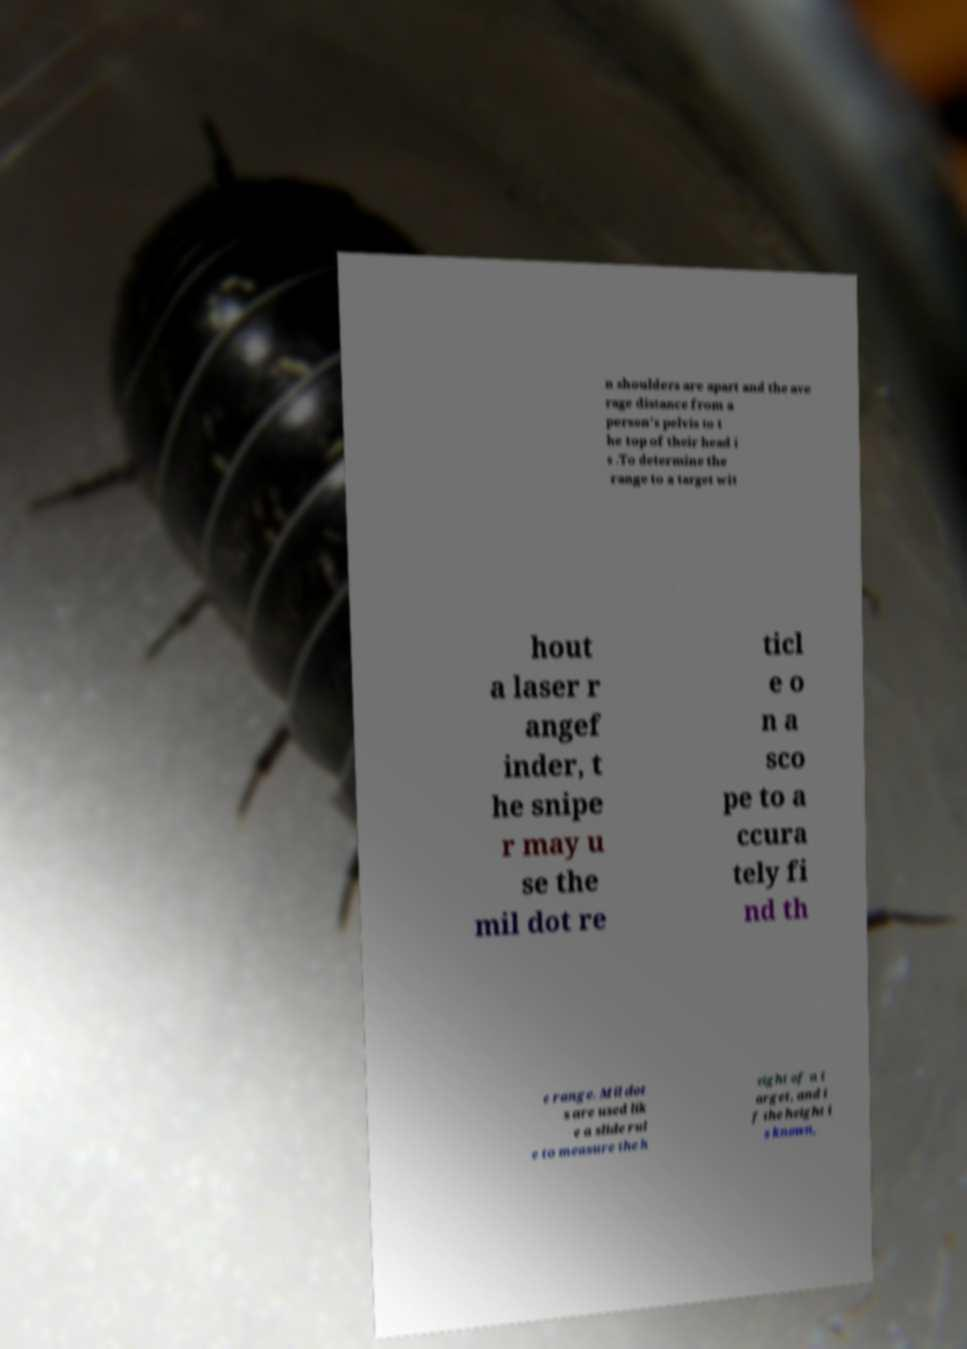Could you assist in decoding the text presented in this image and type it out clearly? n shoulders are apart and the ave rage distance from a person's pelvis to t he top of their head i s .To determine the range to a target wit hout a laser r angef inder, t he snipe r may u se the mil dot re ticl e o n a sco pe to a ccura tely fi nd th e range. Mil dot s are used lik e a slide rul e to measure the h eight of a t arget, and i f the height i s known, 